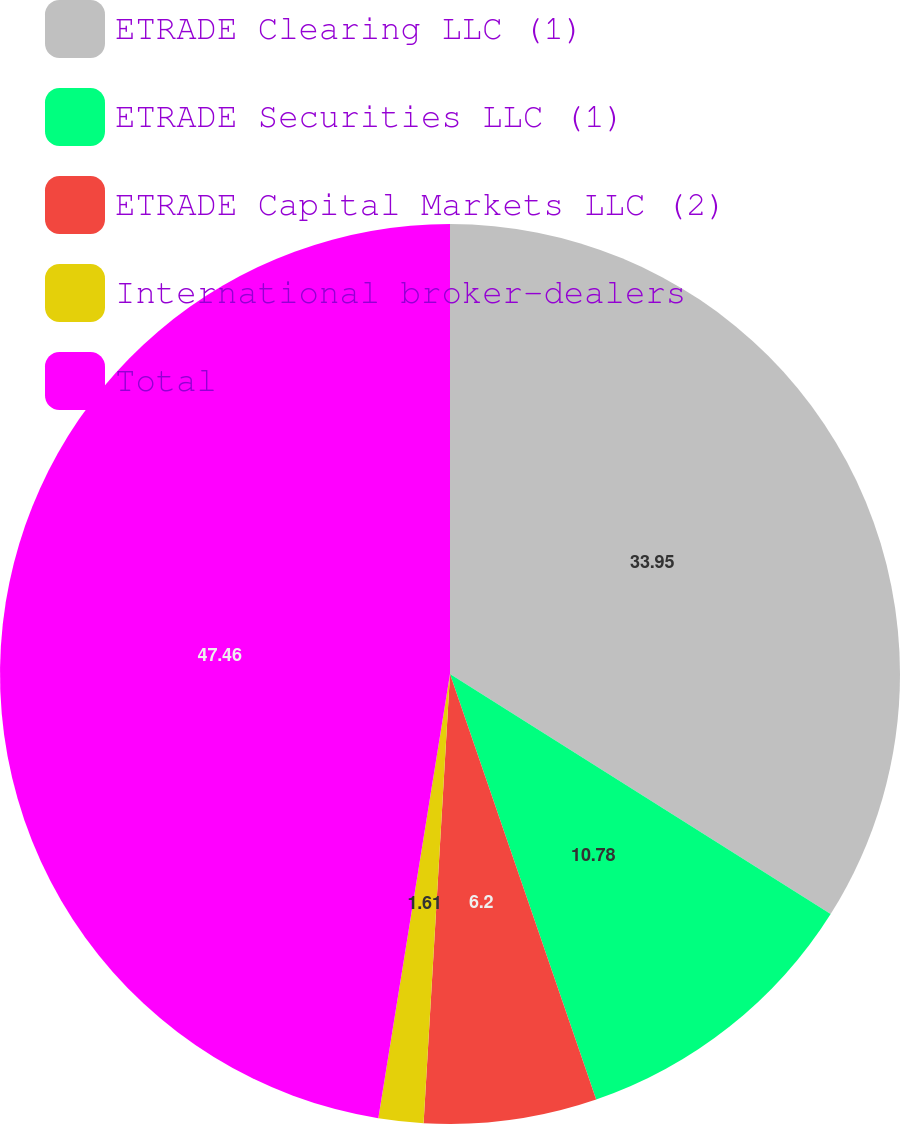<chart> <loc_0><loc_0><loc_500><loc_500><pie_chart><fcel>ETRADE Clearing LLC (1)<fcel>ETRADE Securities LLC (1)<fcel>ETRADE Capital Markets LLC (2)<fcel>International broker-dealers<fcel>Total<nl><fcel>33.95%<fcel>10.78%<fcel>6.2%<fcel>1.61%<fcel>47.45%<nl></chart> 